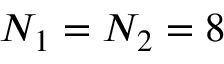Convert formula to latex. <formula><loc_0><loc_0><loc_500><loc_500>N _ { 1 } = N _ { 2 } = 8</formula> 